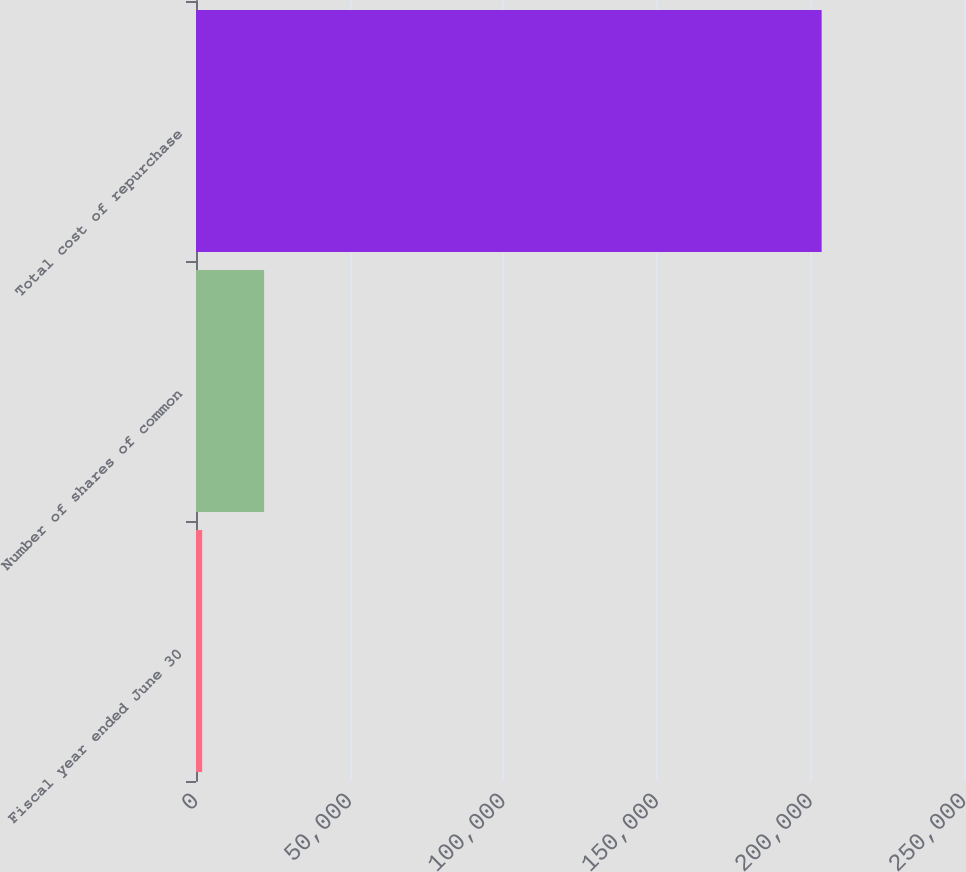<chart> <loc_0><loc_0><loc_500><loc_500><bar_chart><fcel>Fiscal year ended June 30<fcel>Number of shares of common<fcel>Total cost of repurchase<nl><fcel>2005<fcel>22170.3<fcel>203658<nl></chart> 